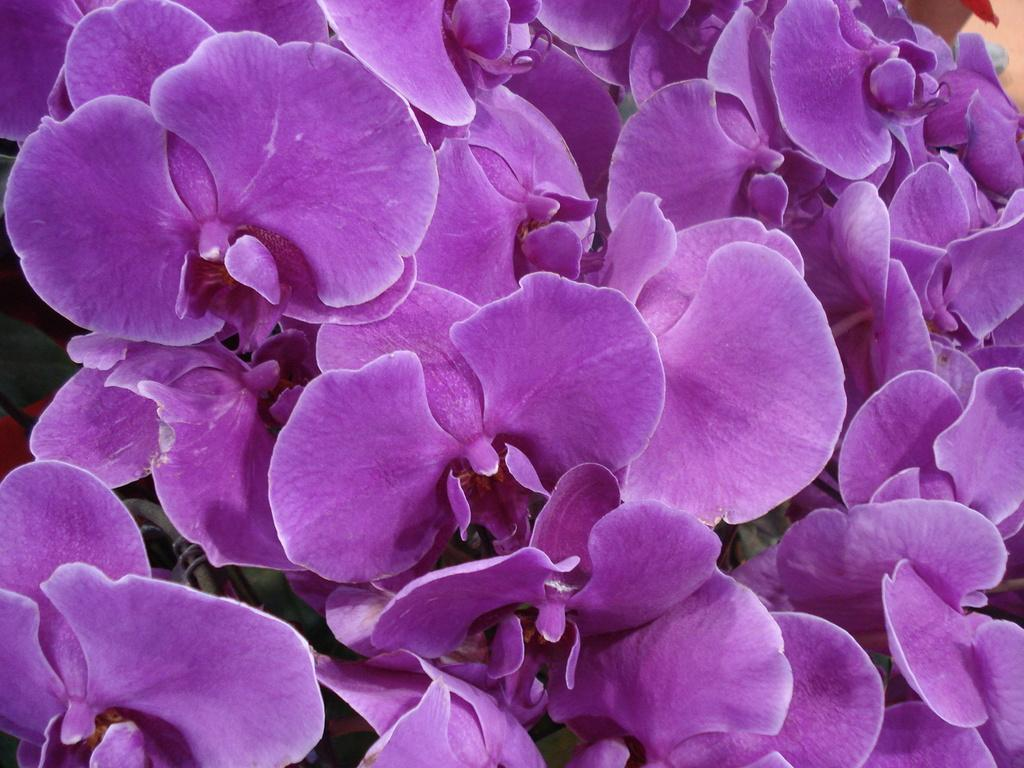What type of living organisms can be seen in the image? Flowers can be seen in the image. What part of the natural environment do the flowers belong to? The flowers belong to the plant kingdom. What might be the purpose of the flowers in the image? The flowers might be for decoration or may be part of a garden. What is the maid doing in the image? There is no maid present in the image; it only features flowers. 